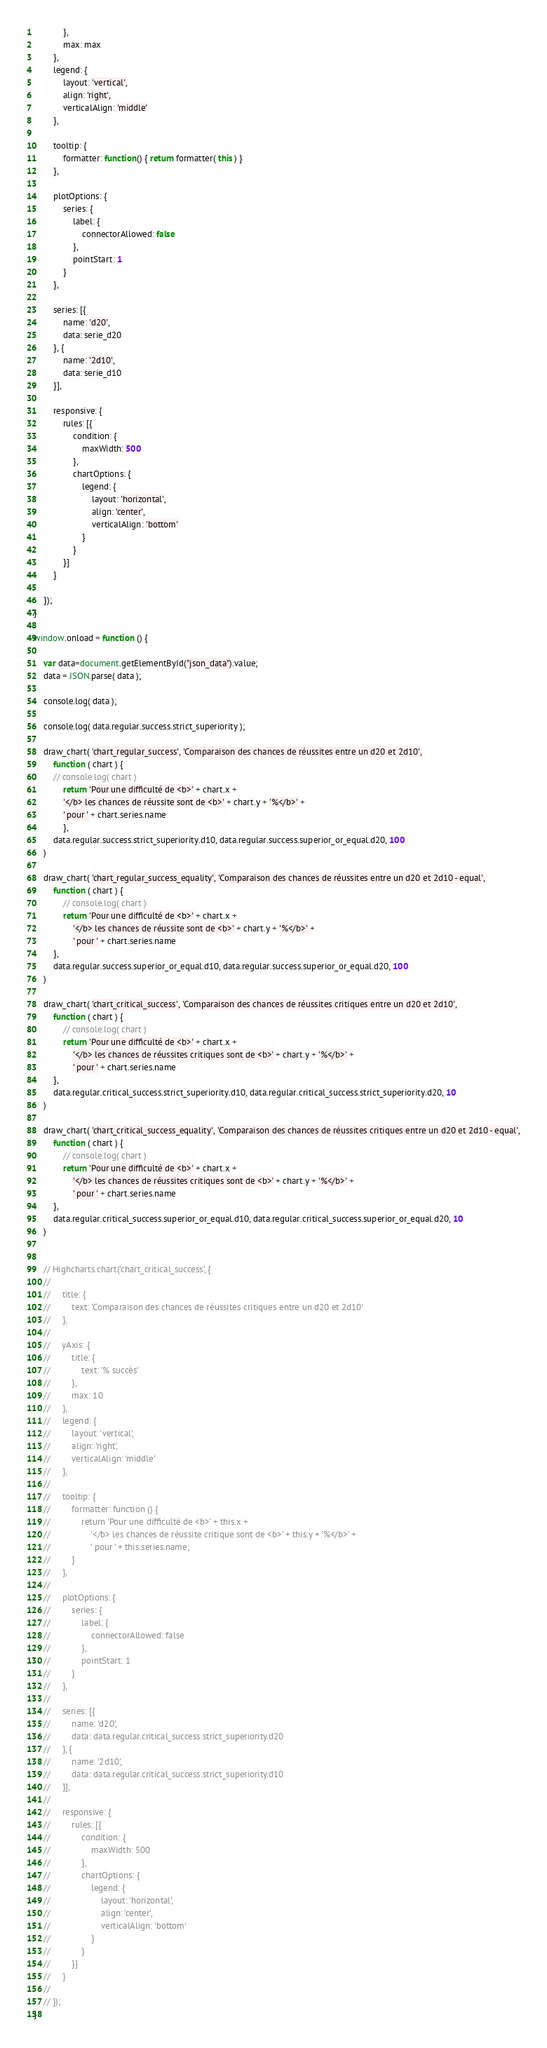<code> <loc_0><loc_0><loc_500><loc_500><_JavaScript_>            },
            max: max
        },
        legend: {
            layout: 'vertical',
            align: 'right',
            verticalAlign: 'middle'
        },

        tooltip: {
            formatter: function() { return formatter( this ) }
        },

        plotOptions: {
            series: {
                label: {
                    connectorAllowed: false
                },
                pointStart: 1
            }
        },

        series: [{
            name: 'd20',
            data: serie_d20
        }, {
            name: '2d10',
            data: serie_d10
        }],

        responsive: {
            rules: [{
                condition: {
                    maxWidth: 500
                },
                chartOptions: {
                    legend: {
                        layout: 'horizontal',
                        align: 'center',
                        verticalAlign: 'bottom'
                    }
                }
            }]
        }

    });
}

window.onload = function () {

    var data=document.getElementById("json_data").value;
    data = JSON.parse( data );

    console.log( data );

    console.log( data.regular.success.strict_superiority );

    draw_chart( 'chart_regular_success', 'Comparaison des chances de réussites entre un d20 et 2d10',
        function ( chart ) {
        // console.log( chart )
            return 'Pour une difficulté de <b>' + chart.x +
            '</b> les chances de réussite sont de <b>' + chart.y + '%</b>' +
            ' pour ' + chart.series.name
            },
        data.regular.success.strict_superiority.d10, data.regular.success.superior_or_equal.d20, 100
    )

    draw_chart( 'chart_regular_success_equality', 'Comparaison des chances de réussites entre un d20 et 2d10 - equal',
        function ( chart ) {
            // console.log( chart )
            return 'Pour une difficulté de <b>' + chart.x +
                '</b> les chances de réussite sont de <b>' + chart.y + '%</b>' +
                ' pour ' + chart.series.name
        },
        data.regular.success.superior_or_equal.d10, data.regular.success.superior_or_equal.d20, 100
    )

    draw_chart( 'chart_critical_success', 'Comparaison des chances de réussites critiques entre un d20 et 2d10',
        function ( chart ) {
            // console.log( chart )
            return 'Pour une difficulté de <b>' + chart.x +
                '</b> les chances de réussites critiques sont de <b>' + chart.y + '%</b>' +
                ' pour ' + chart.series.name
        },
        data.regular.critical_success.strict_superiority.d10, data.regular.critical_success.strict_superiority.d20, 10
    )

    draw_chart( 'chart_critical_success_equality', 'Comparaison des chances de réussites critiques entre un d20 et 2d10 - equal',
        function ( chart ) {
            // console.log( chart )
            return 'Pour une difficulté de <b>' + chart.x +
                '</b> les chances de réussites critiques sont de <b>' + chart.y + '%</b>' +
                ' pour ' + chart.series.name
        },
        data.regular.critical_success.superior_or_equal.d10, data.regular.critical_success.superior_or_equal.d20, 10
    )


    // Highcharts.chart('chart_critical_success', {
    //
    //     title: {
    //         text: 'Comparaison des chances de réussites critiques entre un d20 et 2d10'
    //     },
    //
    //     yAxis: {
    //         title: {
    //             text: '% succès'
    //         },
    //         max: 10
    //     },
    //     legend: {
    //         layout: 'vertical',
    //         align: 'right',
    //         verticalAlign: 'middle'
    //     },
    //
    //     tooltip: {
    //         formatter: function () {
    //             return 'Pour une difficulté de <b>' + this.x +
    //                 '</b> les chances de réussite critique sont de <b>' + this.y + '%</b>' +
    //                 ' pour ' + this.series.name;
    //         }
    //     },
    //
    //     plotOptions: {
    //         series: {
    //             label: {
    //                 connectorAllowed: false
    //             },
    //             pointStart: 1
    //         }
    //     },
    //
    //     series: [{
    //         name: 'd20',
    //         data: data.regular.critical_success.strict_superiority.d20
    //     }, {
    //         name: '2d10',
    //         data: data.regular.critical_success.strict_superiority.d10
    //     }],
    //
    //     responsive: {
    //         rules: [{
    //             condition: {
    //                 maxWidth: 500
    //             },
    //             chartOptions: {
    //                 legend: {
    //                     layout: 'horizontal',
    //                     align: 'center',
    //                     verticalAlign: 'bottom'
    //                 }
    //             }
    //         }]
    //     }
    //
    // });
}</code> 